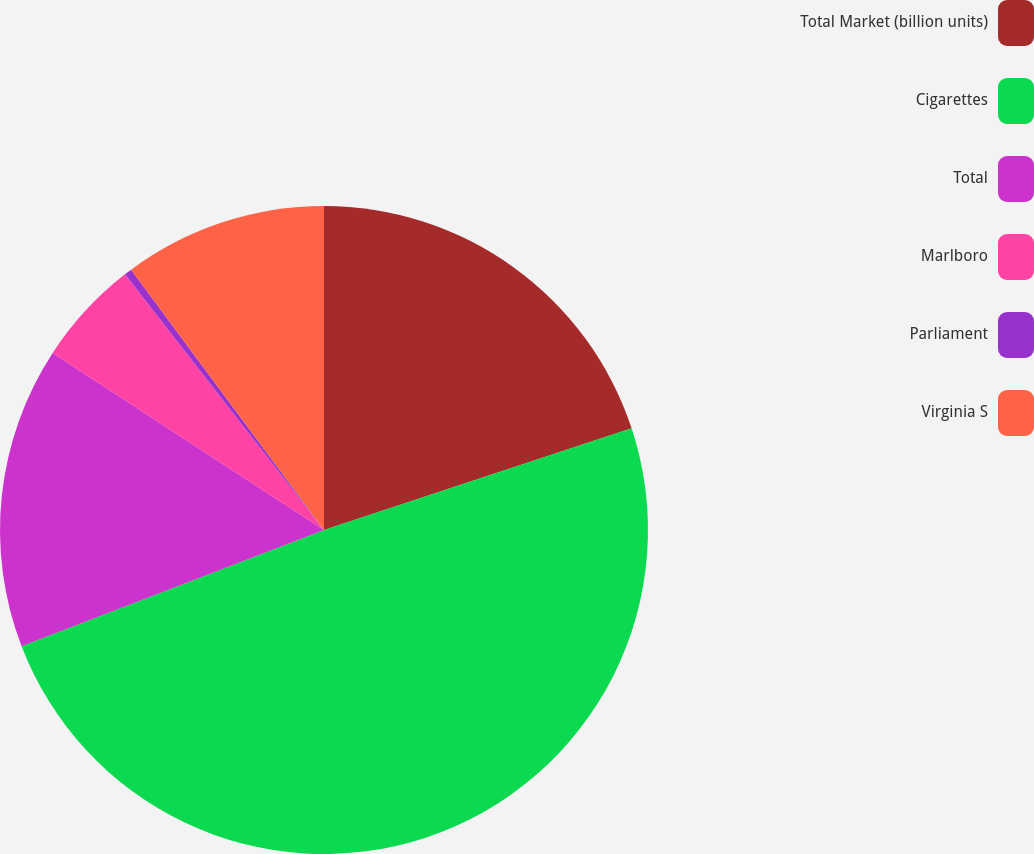Convert chart. <chart><loc_0><loc_0><loc_500><loc_500><pie_chart><fcel>Total Market (billion units)<fcel>Cigarettes<fcel>Total<fcel>Marlboro<fcel>Parliament<fcel>Virginia S<nl><fcel>19.92%<fcel>49.24%<fcel>15.04%<fcel>5.27%<fcel>0.38%<fcel>10.15%<nl></chart> 